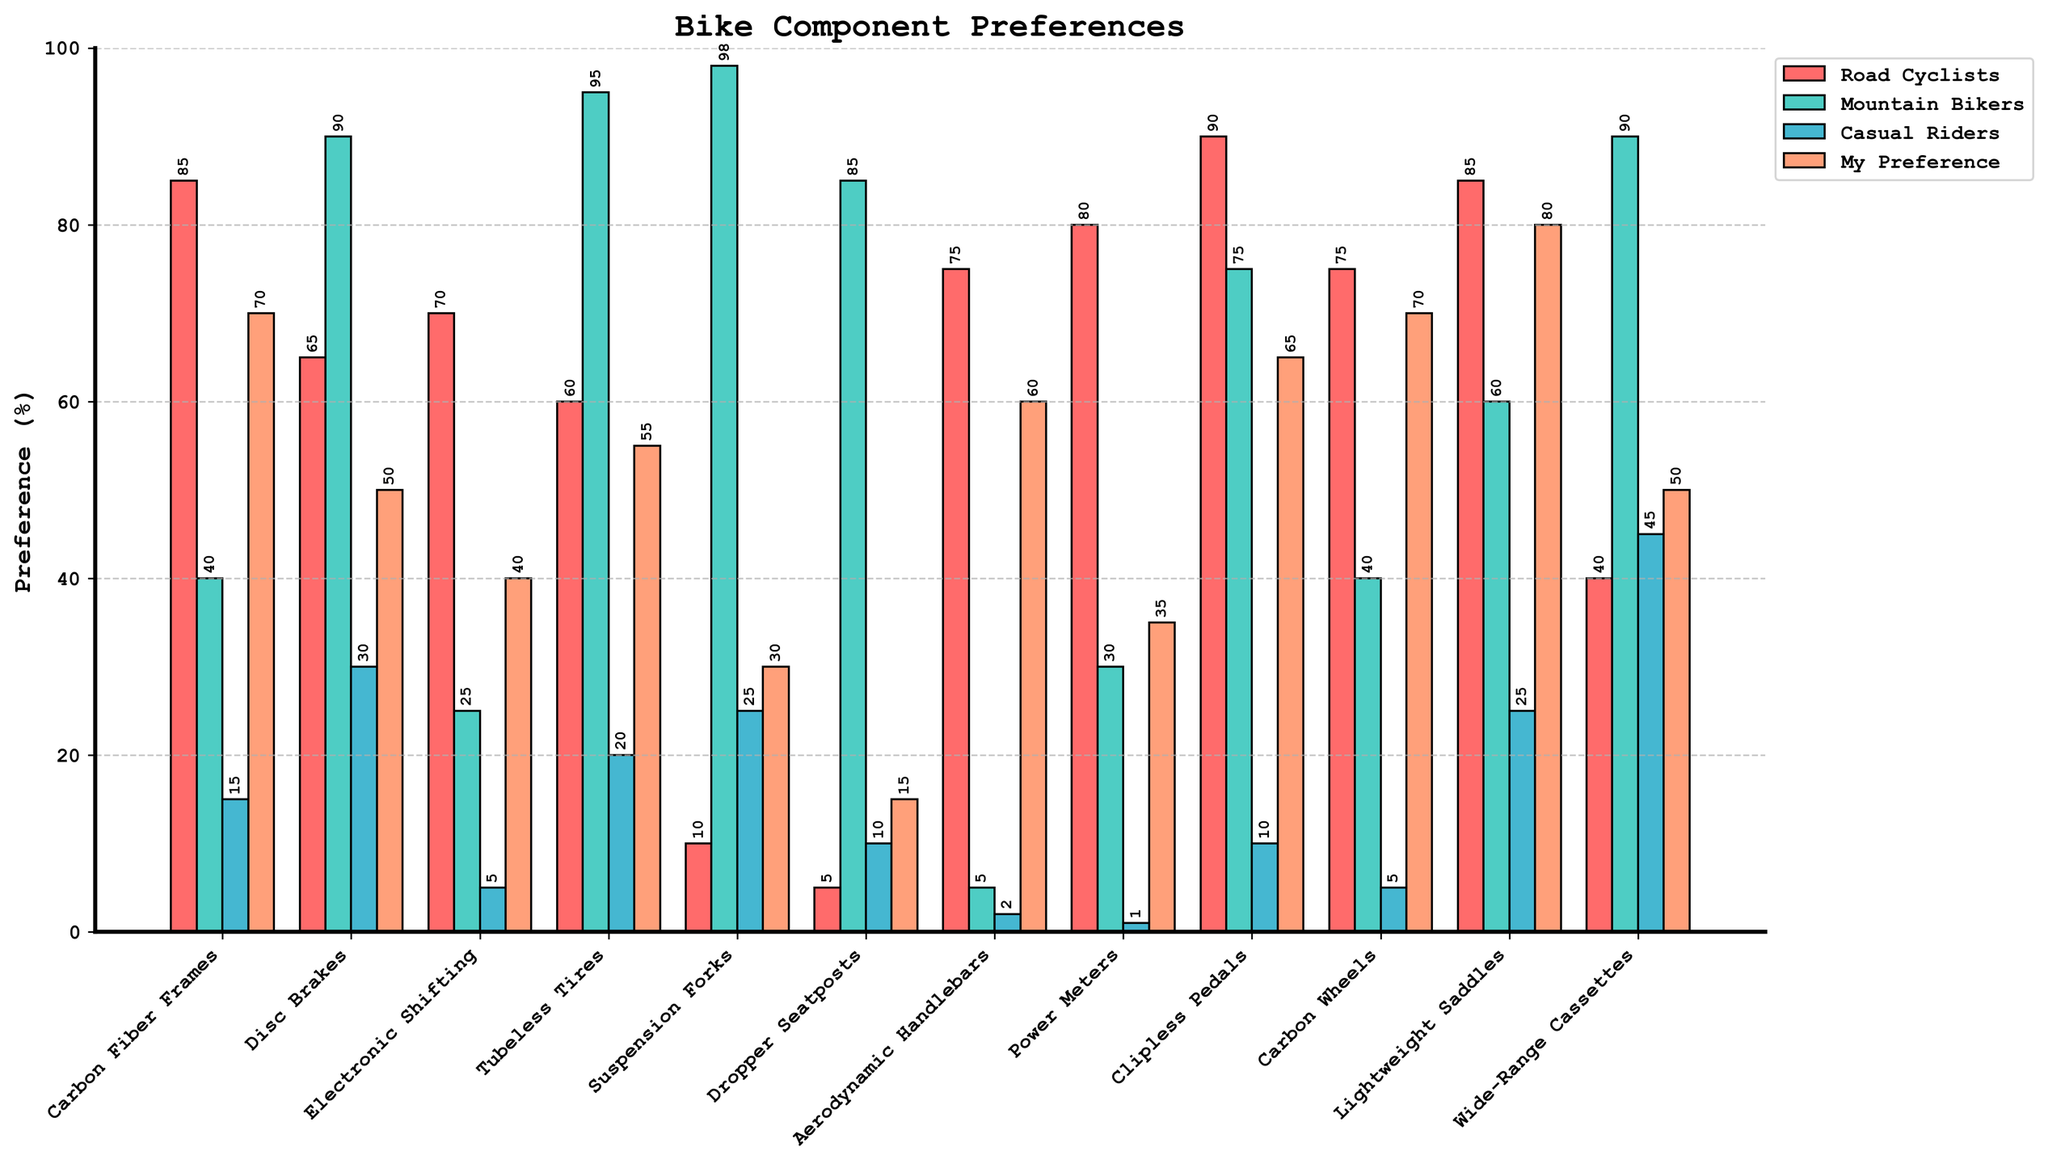Which group has the highest preference for Carbon Fiber Frames? The preferences for Carbon Fiber Frames are: Road Cyclists (85), Mountain Bikers (40), Casual Riders (15), and My Preference (70). The highest preference is by Road Cyclists with a value of 85.
Answer: Road Cyclists What is the difference in preference for Disc Brakes between Mountain Bikers and Casual Riders? The preferences for Disc Brakes are: Mountain Bikers (90) and Casual Riders (30). The difference is 90 - 30 = 60.
Answer: 60 Which component has the lowest preference among Road Cyclists? The preferences for Road Cyclists are: Carbon Fiber Frames (85), Disc Brakes (65), Electronic Shifting (70), Tubeless Tires (60), Suspension Forks (10), Dropper Seatposts (5), Aerodynamic Handlebars (75), Power Meters (80), Clipless Pedals (90), Carbon Wheels (75), Lightweight Saddles (85), Wide-Range Cassettes (40). Dropper Seatposts have the lowest preference with a value of 5.
Answer: Dropper Seatposts How does your preference for Power Meters compare to Road Cyclists? The preferences for Power Meters are: Road Cyclists (80) and My Preference (35). Comparing the two, Road Cyclists' preference (80) is greater than My Preference (35).
Answer: Road Cyclists' preference is higher What is the average preference for Tubeless Tires across all groups? The preferences for Tubeless Tires are: Road Cyclists (60), Mountain Bikers (95), Casual Riders (20), and My Preference (55). The sum is 60 + 95 + 20 + 55 = 230. The average is 230/4 = 57.5.
Answer: 57.5 Which component has a preference of 70 among My Preferences? The components and their preferences among My Preferences are: Carbon Fiber Frames (70), Disc Brakes (50), Electronic Shifting (40), Tubeless Tires (55), Suspension Forks (30), Dropper Seatposts (15), Aerodynamic Handlebars (60), Power Meters (35), Clipless Pedals (65), Carbon Wheels (70), Lightweight Saddles (80), Wide-Range Cassettes (50). Both Carbon Fiber Frames and Carbon Wheels have a preference of 70.
Answer: Carbon Fiber Frames and Carbon Wheels Which group has the lowest preference for Electronic Shifting? The preferences for Electronic Shifting are: Road Cyclists (70), Mountain Bikers (25), Casual Riders (5), and My Preference (40). The lowest preference is among Casual Riders with a value of 5.
Answer: Casual Riders Compare the preference for Clipless Pedals between Mountain Bikers and My Preference. Which one is higher and by how much? The preferences for Clipless Pedals are: Mountain Bikers (75) and My Preference (65). Comparing the two, Mountain Bikers' preference (75) is higher than My Preference (65) by 75 - 65 = 10.
Answer: Mountain Bikers' preference is higher by 10 